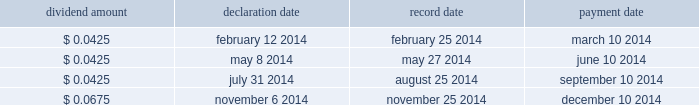Overview we finance our operations and capital expenditures through a combination of internally generated cash from operations and from borrowings under our senior secured asset-based revolving credit facility .
We believe that our current sources of funds will be sufficient to fund our cash operating requirements for the next year .
In addition , we believe that , in spite of the uncertainty of future macroeconomic conditions , we have adequate sources of liquidity and funding available to meet our longer-term needs .
However , there are a number of factors that may negatively impact our available sources of funds .
The amount of cash generated from operations will be dependent upon factors such as the successful execution of our business plan and general economic conditions .
Long-term debt activities during the year ended december 31 , 2014 , we had significant debt refinancings .
In connection with these refinancings , we recorded a loss on extinguishment of long-term debt of $ 90.7 million in our consolidated statement of operations for the year ended december 31 , 2014 .
See note 7 to the accompanying audited consolidated financial statements included elsewhere in this report for additional details .
Share repurchase program on november 6 , 2014 , we announced that our board of directors approved a $ 500 million share repurchase program effective immediately under which we may repurchase shares of our common stock in the open market or through privately negotiated transactions , depending on share price , market conditions and other factors .
The share repurchase program does not obligate us to repurchase any dollar amount or number of shares , and repurchases may be commenced or suspended from time to time without prior notice .
As of the date of this filing , no shares have been repurchased under the share repurchase program .
Dividends a summary of 2014 dividend activity for our common stock is shown below: .
On february 10 , 2015 , we announced that our board of directors declared a quarterly cash dividend on our common stock of $ 0.0675 per share .
The dividend will be paid on march 10 , 2015 to all stockholders of record as of the close of business on february 25 , 2015 .
The payment of any future dividends will be at the discretion of our board of directors and will depend upon our results of operations , financial condition , business prospects , capital requirements , contractual restrictions , any potential indebtedness we may incur , restrictions imposed by applicable law , tax considerations and other factors that our board of directors deems relevant .
In addition , our ability to pay dividends on our common stock will be limited by restrictions on our ability to pay dividends or make distributions to our stockholders and on the ability of our subsidiaries to pay dividends or make distributions to us , in each case , under the terms of our current and any future agreements governing our indebtedness .
Table of contents .
Was the dividend declared on february 10 , 2015 greater than the quarterly cash dividend on our common stock declared on february 12 2014? 
Computations: (0.0675 > 0.0425)
Answer: yes. 